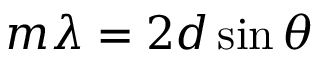<formula> <loc_0><loc_0><loc_500><loc_500>m \lambda = 2 d \sin \theta</formula> 